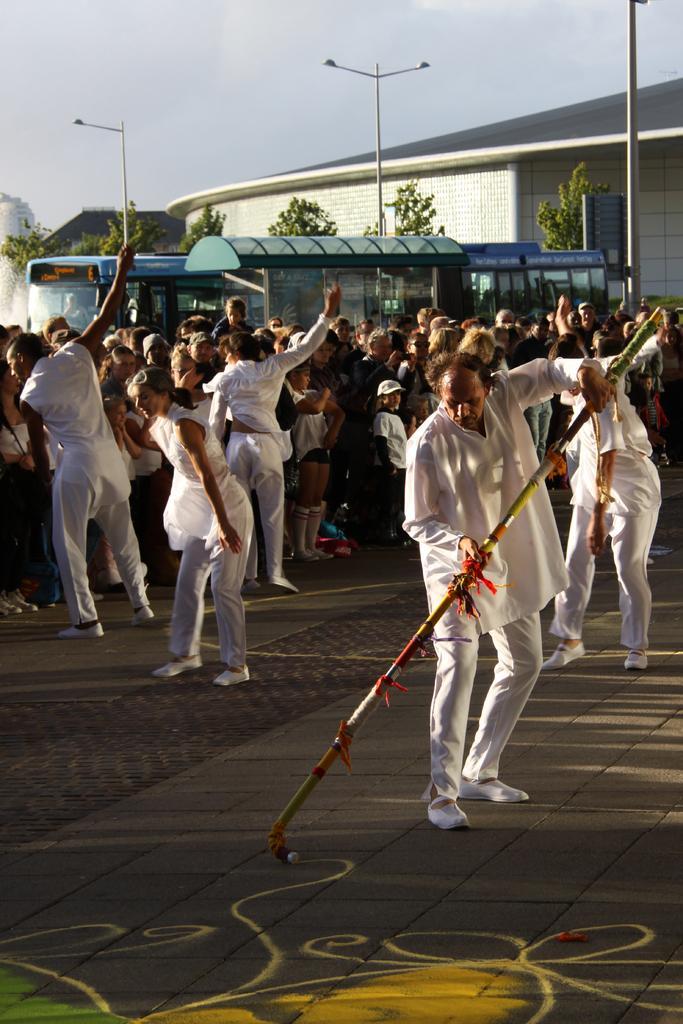How would you summarize this image in a sentence or two? In this image we can see a group of people standing on the ground. One person is holding a stick with his hands. In the center of the image we can see some vehicles, a shed. In the background, we can see a group of trees, buildings and some light poles. At the top of the image we can see the sky. 